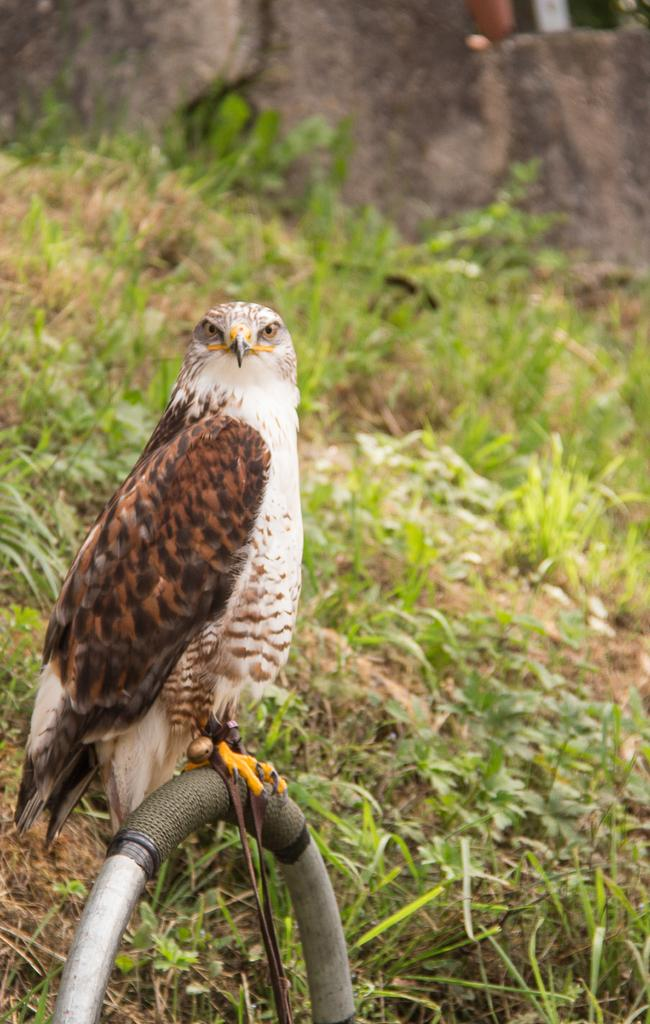What type of animal is present in the image? There is a bird in the image. Where is the bird located? The bird is on an object in the image. What other natural elements can be seen in the image? There are plants and grass in the image. What additional object is present in the image? There is a rock in the image. How would you describe the background of the image? The background of the image is blurred. Where is the nearest store to the bird in the image? There is no store present in the image, as it features a bird on an object with plants, grass, and a rock in a natural setting. 